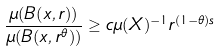<formula> <loc_0><loc_0><loc_500><loc_500>\frac { \mu ( B ( x , r ) ) } { \mu ( B ( x , r ^ { \theta } ) ) } \geq c \mu ( X ) ^ { - 1 } r ^ { ( 1 - \theta ) s }</formula> 